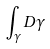<formula> <loc_0><loc_0><loc_500><loc_500>\int _ { \gamma } D \gamma</formula> 